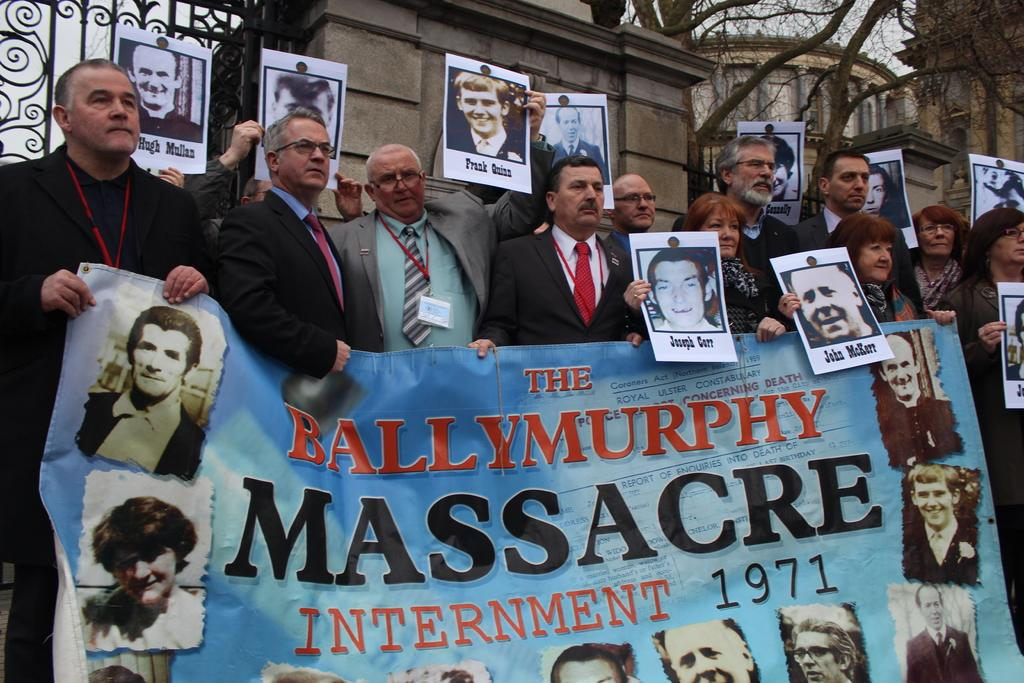What are the people in the image doing? The people in the image are standing and holding placards and banners. What can be seen in the background of the image? There is a building in the background of the image. What is the building's entrance made of? The building has a metal gate. What type of vegetation is visible in the image? There is a tree visible in the image. What type of sand can be seen on the people's noses in the image? There is no sand or noses visible in the image; the people are holding placards and banners. 